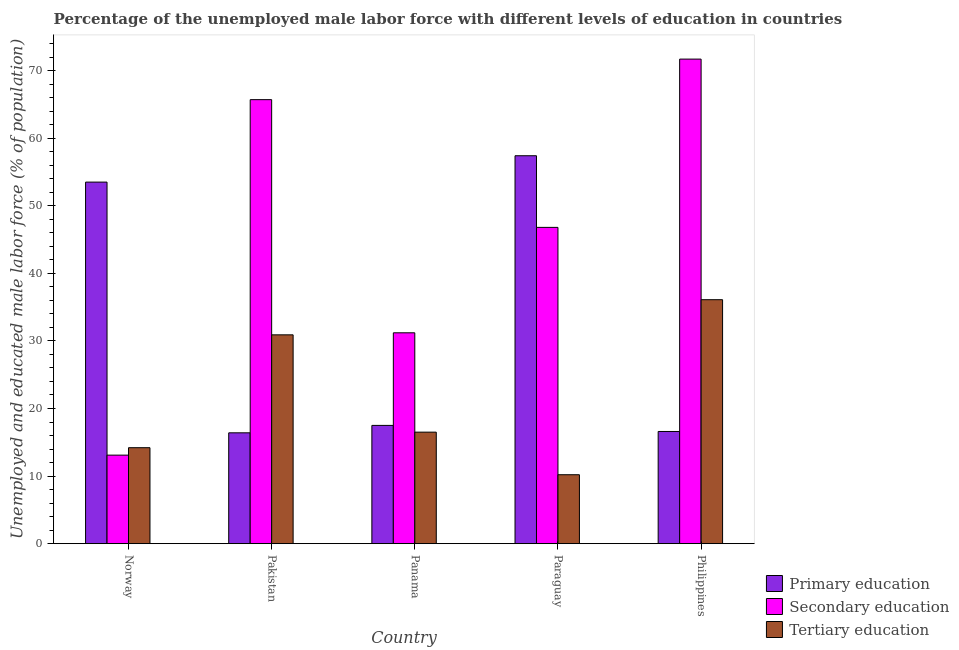How many different coloured bars are there?
Give a very brief answer. 3. Are the number of bars per tick equal to the number of legend labels?
Provide a succinct answer. Yes. Are the number of bars on each tick of the X-axis equal?
Make the answer very short. Yes. How many bars are there on the 1st tick from the left?
Provide a succinct answer. 3. What is the label of the 3rd group of bars from the left?
Make the answer very short. Panama. In how many cases, is the number of bars for a given country not equal to the number of legend labels?
Ensure brevity in your answer.  0. What is the percentage of male labor force who received primary education in Paraguay?
Make the answer very short. 57.4. Across all countries, what is the maximum percentage of male labor force who received secondary education?
Make the answer very short. 71.7. Across all countries, what is the minimum percentage of male labor force who received secondary education?
Provide a short and direct response. 13.1. In which country was the percentage of male labor force who received primary education maximum?
Your answer should be very brief. Paraguay. In which country was the percentage of male labor force who received secondary education minimum?
Keep it short and to the point. Norway. What is the total percentage of male labor force who received primary education in the graph?
Your answer should be very brief. 161.4. What is the difference between the percentage of male labor force who received tertiary education in Paraguay and that in Philippines?
Keep it short and to the point. -25.9. What is the difference between the percentage of male labor force who received tertiary education in Paraguay and the percentage of male labor force who received secondary education in Norway?
Make the answer very short. -2.9. What is the average percentage of male labor force who received primary education per country?
Make the answer very short. 32.28. What is the difference between the percentage of male labor force who received tertiary education and percentage of male labor force who received primary education in Philippines?
Make the answer very short. 19.5. What is the ratio of the percentage of male labor force who received primary education in Paraguay to that in Philippines?
Your answer should be very brief. 3.46. Is the percentage of male labor force who received primary education in Norway less than that in Philippines?
Your answer should be very brief. No. What is the difference between the highest and the second highest percentage of male labor force who received tertiary education?
Your answer should be compact. 5.2. What is the difference between the highest and the lowest percentage of male labor force who received secondary education?
Make the answer very short. 58.6. Is the sum of the percentage of male labor force who received tertiary education in Panama and Paraguay greater than the maximum percentage of male labor force who received primary education across all countries?
Offer a terse response. No. What does the 3rd bar from the left in Pakistan represents?
Give a very brief answer. Tertiary education. What does the 1st bar from the right in Philippines represents?
Give a very brief answer. Tertiary education. Is it the case that in every country, the sum of the percentage of male labor force who received primary education and percentage of male labor force who received secondary education is greater than the percentage of male labor force who received tertiary education?
Keep it short and to the point. Yes. Are all the bars in the graph horizontal?
Offer a very short reply. No. How many countries are there in the graph?
Your response must be concise. 5. What is the difference between two consecutive major ticks on the Y-axis?
Your response must be concise. 10. Does the graph contain grids?
Ensure brevity in your answer.  No. How many legend labels are there?
Keep it short and to the point. 3. How are the legend labels stacked?
Give a very brief answer. Vertical. What is the title of the graph?
Give a very brief answer. Percentage of the unemployed male labor force with different levels of education in countries. Does "ICT services" appear as one of the legend labels in the graph?
Provide a short and direct response. No. What is the label or title of the X-axis?
Offer a terse response. Country. What is the label or title of the Y-axis?
Offer a very short reply. Unemployed and educated male labor force (% of population). What is the Unemployed and educated male labor force (% of population) of Primary education in Norway?
Provide a short and direct response. 53.5. What is the Unemployed and educated male labor force (% of population) of Secondary education in Norway?
Provide a succinct answer. 13.1. What is the Unemployed and educated male labor force (% of population) of Tertiary education in Norway?
Provide a short and direct response. 14.2. What is the Unemployed and educated male labor force (% of population) of Primary education in Pakistan?
Your answer should be compact. 16.4. What is the Unemployed and educated male labor force (% of population) in Secondary education in Pakistan?
Offer a very short reply. 65.7. What is the Unemployed and educated male labor force (% of population) of Tertiary education in Pakistan?
Provide a short and direct response. 30.9. What is the Unemployed and educated male labor force (% of population) of Primary education in Panama?
Keep it short and to the point. 17.5. What is the Unemployed and educated male labor force (% of population) in Secondary education in Panama?
Your answer should be compact. 31.2. What is the Unemployed and educated male labor force (% of population) in Primary education in Paraguay?
Ensure brevity in your answer.  57.4. What is the Unemployed and educated male labor force (% of population) in Secondary education in Paraguay?
Provide a short and direct response. 46.8. What is the Unemployed and educated male labor force (% of population) of Tertiary education in Paraguay?
Your answer should be compact. 10.2. What is the Unemployed and educated male labor force (% of population) in Primary education in Philippines?
Make the answer very short. 16.6. What is the Unemployed and educated male labor force (% of population) in Secondary education in Philippines?
Give a very brief answer. 71.7. What is the Unemployed and educated male labor force (% of population) in Tertiary education in Philippines?
Your response must be concise. 36.1. Across all countries, what is the maximum Unemployed and educated male labor force (% of population) in Primary education?
Offer a very short reply. 57.4. Across all countries, what is the maximum Unemployed and educated male labor force (% of population) in Secondary education?
Offer a terse response. 71.7. Across all countries, what is the maximum Unemployed and educated male labor force (% of population) in Tertiary education?
Offer a terse response. 36.1. Across all countries, what is the minimum Unemployed and educated male labor force (% of population) of Primary education?
Provide a succinct answer. 16.4. Across all countries, what is the minimum Unemployed and educated male labor force (% of population) of Secondary education?
Make the answer very short. 13.1. Across all countries, what is the minimum Unemployed and educated male labor force (% of population) of Tertiary education?
Your response must be concise. 10.2. What is the total Unemployed and educated male labor force (% of population) in Primary education in the graph?
Your response must be concise. 161.4. What is the total Unemployed and educated male labor force (% of population) of Secondary education in the graph?
Your response must be concise. 228.5. What is the total Unemployed and educated male labor force (% of population) in Tertiary education in the graph?
Your response must be concise. 107.9. What is the difference between the Unemployed and educated male labor force (% of population) in Primary education in Norway and that in Pakistan?
Offer a terse response. 37.1. What is the difference between the Unemployed and educated male labor force (% of population) in Secondary education in Norway and that in Pakistan?
Offer a terse response. -52.6. What is the difference between the Unemployed and educated male labor force (% of population) of Tertiary education in Norway and that in Pakistan?
Offer a very short reply. -16.7. What is the difference between the Unemployed and educated male labor force (% of population) in Secondary education in Norway and that in Panama?
Your response must be concise. -18.1. What is the difference between the Unemployed and educated male labor force (% of population) of Tertiary education in Norway and that in Panama?
Your answer should be very brief. -2.3. What is the difference between the Unemployed and educated male labor force (% of population) of Primary education in Norway and that in Paraguay?
Make the answer very short. -3.9. What is the difference between the Unemployed and educated male labor force (% of population) in Secondary education in Norway and that in Paraguay?
Make the answer very short. -33.7. What is the difference between the Unemployed and educated male labor force (% of population) in Tertiary education in Norway and that in Paraguay?
Offer a terse response. 4. What is the difference between the Unemployed and educated male labor force (% of population) in Primary education in Norway and that in Philippines?
Make the answer very short. 36.9. What is the difference between the Unemployed and educated male labor force (% of population) of Secondary education in Norway and that in Philippines?
Make the answer very short. -58.6. What is the difference between the Unemployed and educated male labor force (% of population) in Tertiary education in Norway and that in Philippines?
Your response must be concise. -21.9. What is the difference between the Unemployed and educated male labor force (% of population) in Secondary education in Pakistan and that in Panama?
Your response must be concise. 34.5. What is the difference between the Unemployed and educated male labor force (% of population) of Tertiary education in Pakistan and that in Panama?
Your response must be concise. 14.4. What is the difference between the Unemployed and educated male labor force (% of population) in Primary education in Pakistan and that in Paraguay?
Provide a succinct answer. -41. What is the difference between the Unemployed and educated male labor force (% of population) in Tertiary education in Pakistan and that in Paraguay?
Provide a short and direct response. 20.7. What is the difference between the Unemployed and educated male labor force (% of population) in Primary education in Pakistan and that in Philippines?
Your answer should be very brief. -0.2. What is the difference between the Unemployed and educated male labor force (% of population) of Secondary education in Pakistan and that in Philippines?
Provide a short and direct response. -6. What is the difference between the Unemployed and educated male labor force (% of population) of Primary education in Panama and that in Paraguay?
Your answer should be compact. -39.9. What is the difference between the Unemployed and educated male labor force (% of population) in Secondary education in Panama and that in Paraguay?
Make the answer very short. -15.6. What is the difference between the Unemployed and educated male labor force (% of population) of Primary education in Panama and that in Philippines?
Provide a short and direct response. 0.9. What is the difference between the Unemployed and educated male labor force (% of population) in Secondary education in Panama and that in Philippines?
Keep it short and to the point. -40.5. What is the difference between the Unemployed and educated male labor force (% of population) in Tertiary education in Panama and that in Philippines?
Your response must be concise. -19.6. What is the difference between the Unemployed and educated male labor force (% of population) of Primary education in Paraguay and that in Philippines?
Provide a succinct answer. 40.8. What is the difference between the Unemployed and educated male labor force (% of population) in Secondary education in Paraguay and that in Philippines?
Your answer should be very brief. -24.9. What is the difference between the Unemployed and educated male labor force (% of population) in Tertiary education in Paraguay and that in Philippines?
Make the answer very short. -25.9. What is the difference between the Unemployed and educated male labor force (% of population) in Primary education in Norway and the Unemployed and educated male labor force (% of population) in Tertiary education in Pakistan?
Your answer should be compact. 22.6. What is the difference between the Unemployed and educated male labor force (% of population) of Secondary education in Norway and the Unemployed and educated male labor force (% of population) of Tertiary education in Pakistan?
Your answer should be very brief. -17.8. What is the difference between the Unemployed and educated male labor force (% of population) in Primary education in Norway and the Unemployed and educated male labor force (% of population) in Secondary education in Panama?
Ensure brevity in your answer.  22.3. What is the difference between the Unemployed and educated male labor force (% of population) in Secondary education in Norway and the Unemployed and educated male labor force (% of population) in Tertiary education in Panama?
Provide a short and direct response. -3.4. What is the difference between the Unemployed and educated male labor force (% of population) of Primary education in Norway and the Unemployed and educated male labor force (% of population) of Tertiary education in Paraguay?
Provide a succinct answer. 43.3. What is the difference between the Unemployed and educated male labor force (% of population) in Primary education in Norway and the Unemployed and educated male labor force (% of population) in Secondary education in Philippines?
Make the answer very short. -18.2. What is the difference between the Unemployed and educated male labor force (% of population) of Primary education in Norway and the Unemployed and educated male labor force (% of population) of Tertiary education in Philippines?
Keep it short and to the point. 17.4. What is the difference between the Unemployed and educated male labor force (% of population) in Primary education in Pakistan and the Unemployed and educated male labor force (% of population) in Secondary education in Panama?
Offer a terse response. -14.8. What is the difference between the Unemployed and educated male labor force (% of population) of Secondary education in Pakistan and the Unemployed and educated male labor force (% of population) of Tertiary education in Panama?
Your answer should be very brief. 49.2. What is the difference between the Unemployed and educated male labor force (% of population) in Primary education in Pakistan and the Unemployed and educated male labor force (% of population) in Secondary education in Paraguay?
Provide a short and direct response. -30.4. What is the difference between the Unemployed and educated male labor force (% of population) of Secondary education in Pakistan and the Unemployed and educated male labor force (% of population) of Tertiary education in Paraguay?
Provide a succinct answer. 55.5. What is the difference between the Unemployed and educated male labor force (% of population) of Primary education in Pakistan and the Unemployed and educated male labor force (% of population) of Secondary education in Philippines?
Ensure brevity in your answer.  -55.3. What is the difference between the Unemployed and educated male labor force (% of population) of Primary education in Pakistan and the Unemployed and educated male labor force (% of population) of Tertiary education in Philippines?
Offer a terse response. -19.7. What is the difference between the Unemployed and educated male labor force (% of population) of Secondary education in Pakistan and the Unemployed and educated male labor force (% of population) of Tertiary education in Philippines?
Provide a succinct answer. 29.6. What is the difference between the Unemployed and educated male labor force (% of population) in Primary education in Panama and the Unemployed and educated male labor force (% of population) in Secondary education in Paraguay?
Your response must be concise. -29.3. What is the difference between the Unemployed and educated male labor force (% of population) in Primary education in Panama and the Unemployed and educated male labor force (% of population) in Tertiary education in Paraguay?
Your response must be concise. 7.3. What is the difference between the Unemployed and educated male labor force (% of population) of Primary education in Panama and the Unemployed and educated male labor force (% of population) of Secondary education in Philippines?
Provide a short and direct response. -54.2. What is the difference between the Unemployed and educated male labor force (% of population) in Primary education in Panama and the Unemployed and educated male labor force (% of population) in Tertiary education in Philippines?
Provide a succinct answer. -18.6. What is the difference between the Unemployed and educated male labor force (% of population) in Secondary education in Panama and the Unemployed and educated male labor force (% of population) in Tertiary education in Philippines?
Your answer should be very brief. -4.9. What is the difference between the Unemployed and educated male labor force (% of population) of Primary education in Paraguay and the Unemployed and educated male labor force (% of population) of Secondary education in Philippines?
Your response must be concise. -14.3. What is the difference between the Unemployed and educated male labor force (% of population) of Primary education in Paraguay and the Unemployed and educated male labor force (% of population) of Tertiary education in Philippines?
Your answer should be compact. 21.3. What is the difference between the Unemployed and educated male labor force (% of population) in Secondary education in Paraguay and the Unemployed and educated male labor force (% of population) in Tertiary education in Philippines?
Your answer should be very brief. 10.7. What is the average Unemployed and educated male labor force (% of population) in Primary education per country?
Make the answer very short. 32.28. What is the average Unemployed and educated male labor force (% of population) in Secondary education per country?
Provide a short and direct response. 45.7. What is the average Unemployed and educated male labor force (% of population) of Tertiary education per country?
Give a very brief answer. 21.58. What is the difference between the Unemployed and educated male labor force (% of population) of Primary education and Unemployed and educated male labor force (% of population) of Secondary education in Norway?
Keep it short and to the point. 40.4. What is the difference between the Unemployed and educated male labor force (% of population) of Primary education and Unemployed and educated male labor force (% of population) of Tertiary education in Norway?
Provide a short and direct response. 39.3. What is the difference between the Unemployed and educated male labor force (% of population) in Secondary education and Unemployed and educated male labor force (% of population) in Tertiary education in Norway?
Provide a succinct answer. -1.1. What is the difference between the Unemployed and educated male labor force (% of population) in Primary education and Unemployed and educated male labor force (% of population) in Secondary education in Pakistan?
Keep it short and to the point. -49.3. What is the difference between the Unemployed and educated male labor force (% of population) of Primary education and Unemployed and educated male labor force (% of population) of Tertiary education in Pakistan?
Provide a succinct answer. -14.5. What is the difference between the Unemployed and educated male labor force (% of population) in Secondary education and Unemployed and educated male labor force (% of population) in Tertiary education in Pakistan?
Provide a short and direct response. 34.8. What is the difference between the Unemployed and educated male labor force (% of population) in Primary education and Unemployed and educated male labor force (% of population) in Secondary education in Panama?
Make the answer very short. -13.7. What is the difference between the Unemployed and educated male labor force (% of population) in Secondary education and Unemployed and educated male labor force (% of population) in Tertiary education in Panama?
Your response must be concise. 14.7. What is the difference between the Unemployed and educated male labor force (% of population) in Primary education and Unemployed and educated male labor force (% of population) in Tertiary education in Paraguay?
Ensure brevity in your answer.  47.2. What is the difference between the Unemployed and educated male labor force (% of population) of Secondary education and Unemployed and educated male labor force (% of population) of Tertiary education in Paraguay?
Make the answer very short. 36.6. What is the difference between the Unemployed and educated male labor force (% of population) of Primary education and Unemployed and educated male labor force (% of population) of Secondary education in Philippines?
Your response must be concise. -55.1. What is the difference between the Unemployed and educated male labor force (% of population) of Primary education and Unemployed and educated male labor force (% of population) of Tertiary education in Philippines?
Provide a short and direct response. -19.5. What is the difference between the Unemployed and educated male labor force (% of population) in Secondary education and Unemployed and educated male labor force (% of population) in Tertiary education in Philippines?
Ensure brevity in your answer.  35.6. What is the ratio of the Unemployed and educated male labor force (% of population) of Primary education in Norway to that in Pakistan?
Make the answer very short. 3.26. What is the ratio of the Unemployed and educated male labor force (% of population) in Secondary education in Norway to that in Pakistan?
Provide a succinct answer. 0.2. What is the ratio of the Unemployed and educated male labor force (% of population) in Tertiary education in Norway to that in Pakistan?
Keep it short and to the point. 0.46. What is the ratio of the Unemployed and educated male labor force (% of population) of Primary education in Norway to that in Panama?
Keep it short and to the point. 3.06. What is the ratio of the Unemployed and educated male labor force (% of population) of Secondary education in Norway to that in Panama?
Your response must be concise. 0.42. What is the ratio of the Unemployed and educated male labor force (% of population) of Tertiary education in Norway to that in Panama?
Ensure brevity in your answer.  0.86. What is the ratio of the Unemployed and educated male labor force (% of population) in Primary education in Norway to that in Paraguay?
Give a very brief answer. 0.93. What is the ratio of the Unemployed and educated male labor force (% of population) of Secondary education in Norway to that in Paraguay?
Offer a terse response. 0.28. What is the ratio of the Unemployed and educated male labor force (% of population) of Tertiary education in Norway to that in Paraguay?
Provide a short and direct response. 1.39. What is the ratio of the Unemployed and educated male labor force (% of population) in Primary education in Norway to that in Philippines?
Keep it short and to the point. 3.22. What is the ratio of the Unemployed and educated male labor force (% of population) in Secondary education in Norway to that in Philippines?
Your answer should be compact. 0.18. What is the ratio of the Unemployed and educated male labor force (% of population) of Tertiary education in Norway to that in Philippines?
Your response must be concise. 0.39. What is the ratio of the Unemployed and educated male labor force (% of population) of Primary education in Pakistan to that in Panama?
Offer a very short reply. 0.94. What is the ratio of the Unemployed and educated male labor force (% of population) in Secondary education in Pakistan to that in Panama?
Provide a succinct answer. 2.11. What is the ratio of the Unemployed and educated male labor force (% of population) in Tertiary education in Pakistan to that in Panama?
Your response must be concise. 1.87. What is the ratio of the Unemployed and educated male labor force (% of population) in Primary education in Pakistan to that in Paraguay?
Make the answer very short. 0.29. What is the ratio of the Unemployed and educated male labor force (% of population) in Secondary education in Pakistan to that in Paraguay?
Your answer should be compact. 1.4. What is the ratio of the Unemployed and educated male labor force (% of population) in Tertiary education in Pakistan to that in Paraguay?
Provide a succinct answer. 3.03. What is the ratio of the Unemployed and educated male labor force (% of population) in Primary education in Pakistan to that in Philippines?
Give a very brief answer. 0.99. What is the ratio of the Unemployed and educated male labor force (% of population) in Secondary education in Pakistan to that in Philippines?
Provide a succinct answer. 0.92. What is the ratio of the Unemployed and educated male labor force (% of population) of Tertiary education in Pakistan to that in Philippines?
Give a very brief answer. 0.86. What is the ratio of the Unemployed and educated male labor force (% of population) in Primary education in Panama to that in Paraguay?
Your answer should be compact. 0.3. What is the ratio of the Unemployed and educated male labor force (% of population) of Tertiary education in Panama to that in Paraguay?
Make the answer very short. 1.62. What is the ratio of the Unemployed and educated male labor force (% of population) of Primary education in Panama to that in Philippines?
Offer a very short reply. 1.05. What is the ratio of the Unemployed and educated male labor force (% of population) of Secondary education in Panama to that in Philippines?
Offer a terse response. 0.44. What is the ratio of the Unemployed and educated male labor force (% of population) in Tertiary education in Panama to that in Philippines?
Provide a short and direct response. 0.46. What is the ratio of the Unemployed and educated male labor force (% of population) of Primary education in Paraguay to that in Philippines?
Your answer should be compact. 3.46. What is the ratio of the Unemployed and educated male labor force (% of population) in Secondary education in Paraguay to that in Philippines?
Your answer should be compact. 0.65. What is the ratio of the Unemployed and educated male labor force (% of population) of Tertiary education in Paraguay to that in Philippines?
Offer a terse response. 0.28. What is the difference between the highest and the second highest Unemployed and educated male labor force (% of population) in Secondary education?
Ensure brevity in your answer.  6. What is the difference between the highest and the second highest Unemployed and educated male labor force (% of population) in Tertiary education?
Your answer should be very brief. 5.2. What is the difference between the highest and the lowest Unemployed and educated male labor force (% of population) of Primary education?
Keep it short and to the point. 41. What is the difference between the highest and the lowest Unemployed and educated male labor force (% of population) in Secondary education?
Keep it short and to the point. 58.6. What is the difference between the highest and the lowest Unemployed and educated male labor force (% of population) of Tertiary education?
Keep it short and to the point. 25.9. 